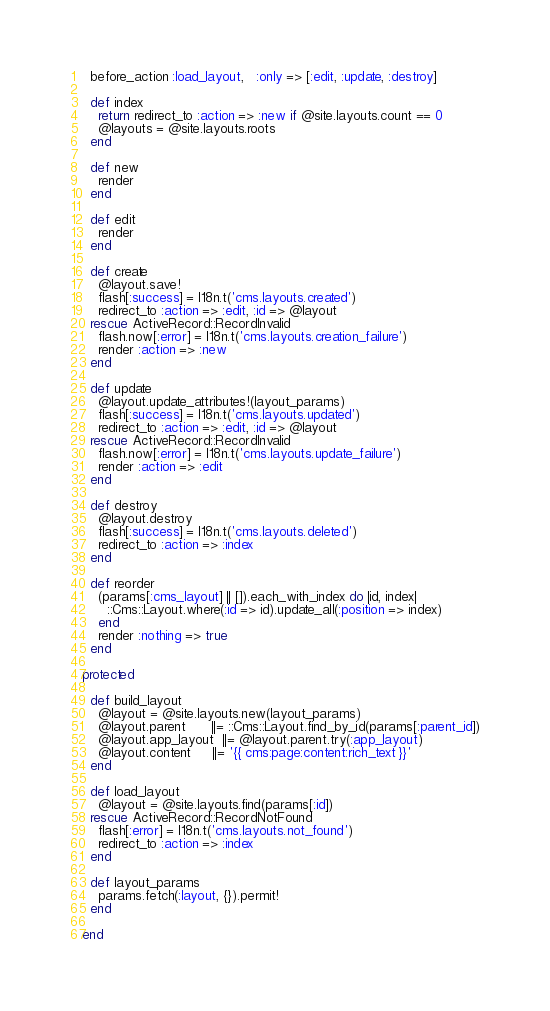Convert code to text. <code><loc_0><loc_0><loc_500><loc_500><_Ruby_>  before_action :load_layout,   :only => [:edit, :update, :destroy]

  def index
    return redirect_to :action => :new if @site.layouts.count == 0
    @layouts = @site.layouts.roots
  end

  def new
    render
  end

  def edit
    render
  end

  def create
    @layout.save!
    flash[:success] = I18n.t('cms.layouts.created')
    redirect_to :action => :edit, :id => @layout
  rescue ActiveRecord::RecordInvalid
    flash.now[:error] = I18n.t('cms.layouts.creation_failure')
    render :action => :new
  end

  def update
    @layout.update_attributes!(layout_params)
    flash[:success] = I18n.t('cms.layouts.updated')
    redirect_to :action => :edit, :id => @layout
  rescue ActiveRecord::RecordInvalid
    flash.now[:error] = I18n.t('cms.layouts.update_failure')
    render :action => :edit
  end

  def destroy
    @layout.destroy
    flash[:success] = I18n.t('cms.layouts.deleted')
    redirect_to :action => :index
  end
  
  def reorder
    (params[:cms_layout] || []).each_with_index do |id, index|
      ::Cms::Layout.where(:id => id).update_all(:position => index)
    end
    render :nothing => true
  end

protected

  def build_layout
    @layout = @site.layouts.new(layout_params)
    @layout.parent      ||= ::Cms::Layout.find_by_id(params[:parent_id])
    @layout.app_layout  ||= @layout.parent.try(:app_layout)
    @layout.content     ||= '{{ cms:page:content:rich_text }}'
  end

  def load_layout
    @layout = @site.layouts.find(params[:id])
  rescue ActiveRecord::RecordNotFound
    flash[:error] = I18n.t('cms.layouts.not_found')
    redirect_to :action => :index
  end
  
  def layout_params
    params.fetch(:layout, {}).permit!
  end
  
end
</code> 